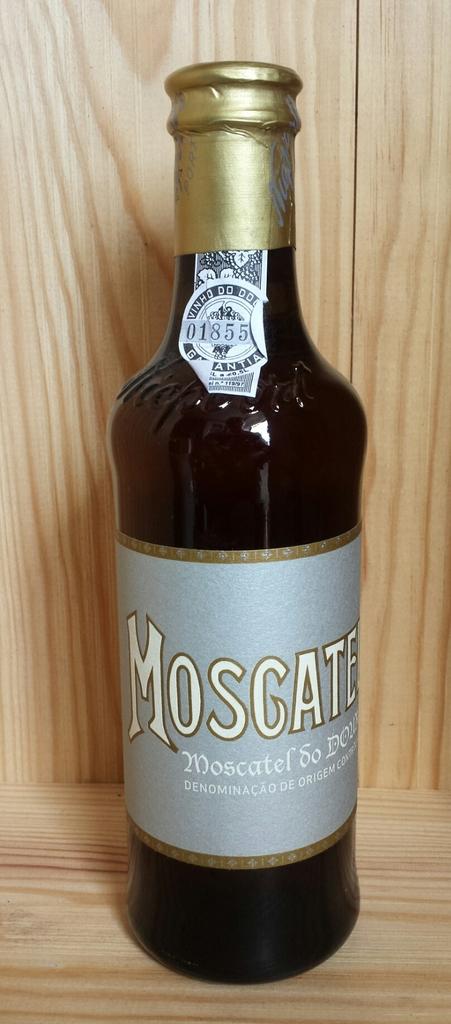What is the brand of the beverage?
Offer a terse response. Moscate. What number is on the sticker at the top of the bottle?
Make the answer very short. 01855. 